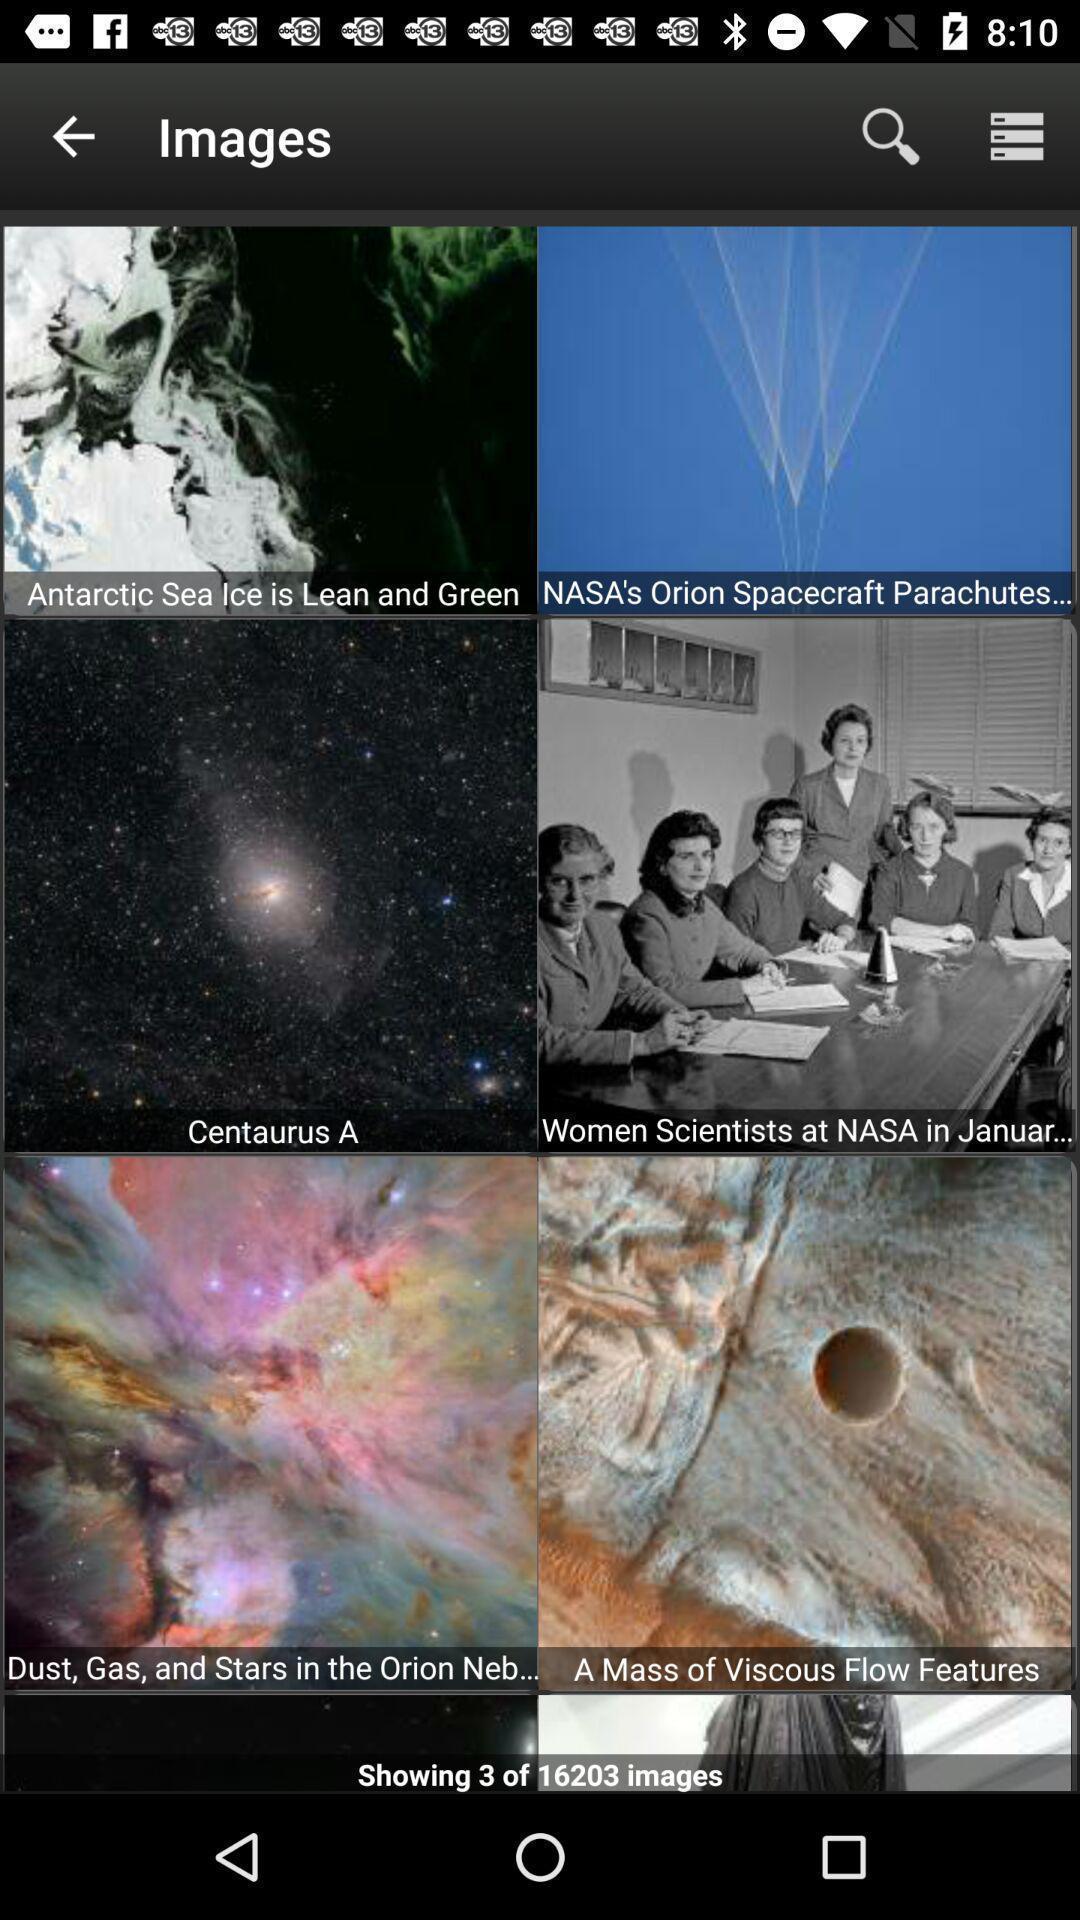Tell me what you see in this picture. Various types of images in the gallery. 